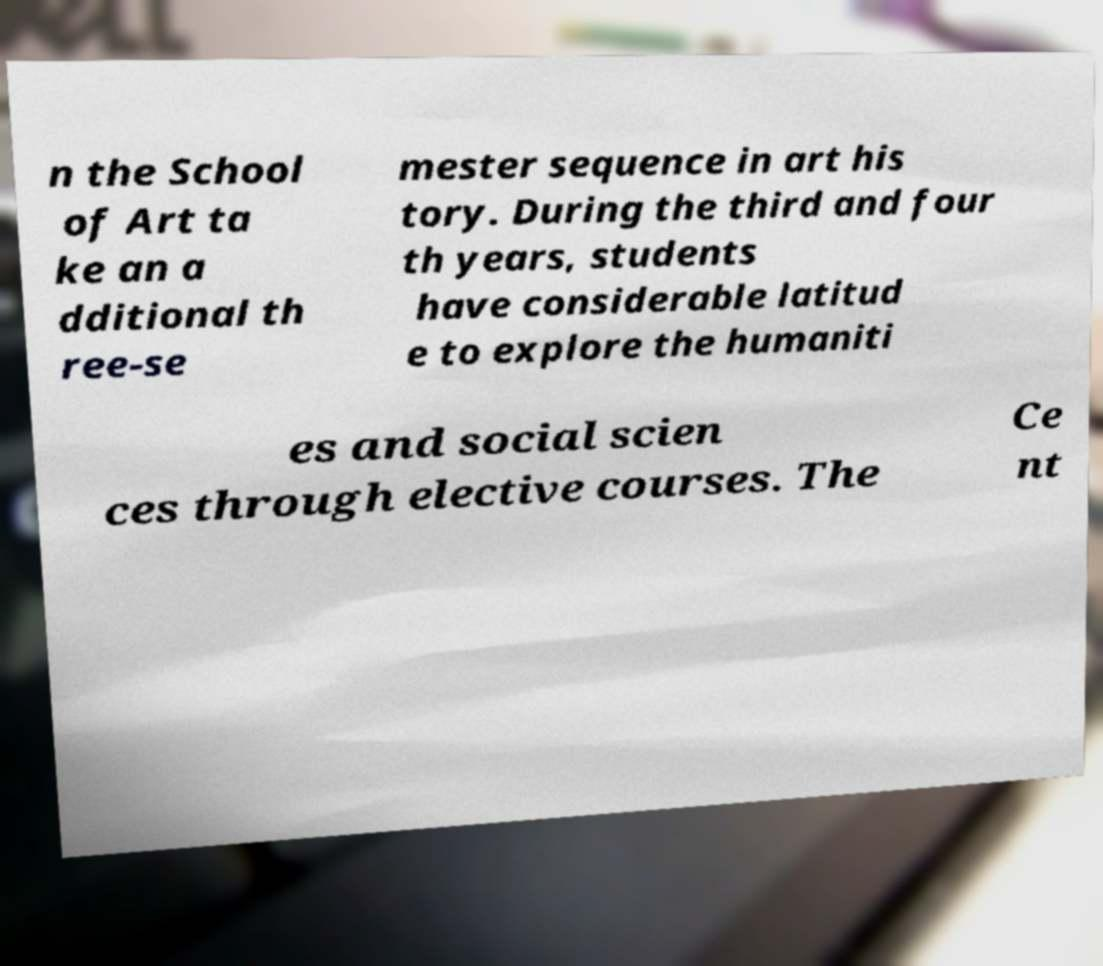For documentation purposes, I need the text within this image transcribed. Could you provide that? n the School of Art ta ke an a dditional th ree-se mester sequence in art his tory. During the third and four th years, students have considerable latitud e to explore the humaniti es and social scien ces through elective courses. The Ce nt 